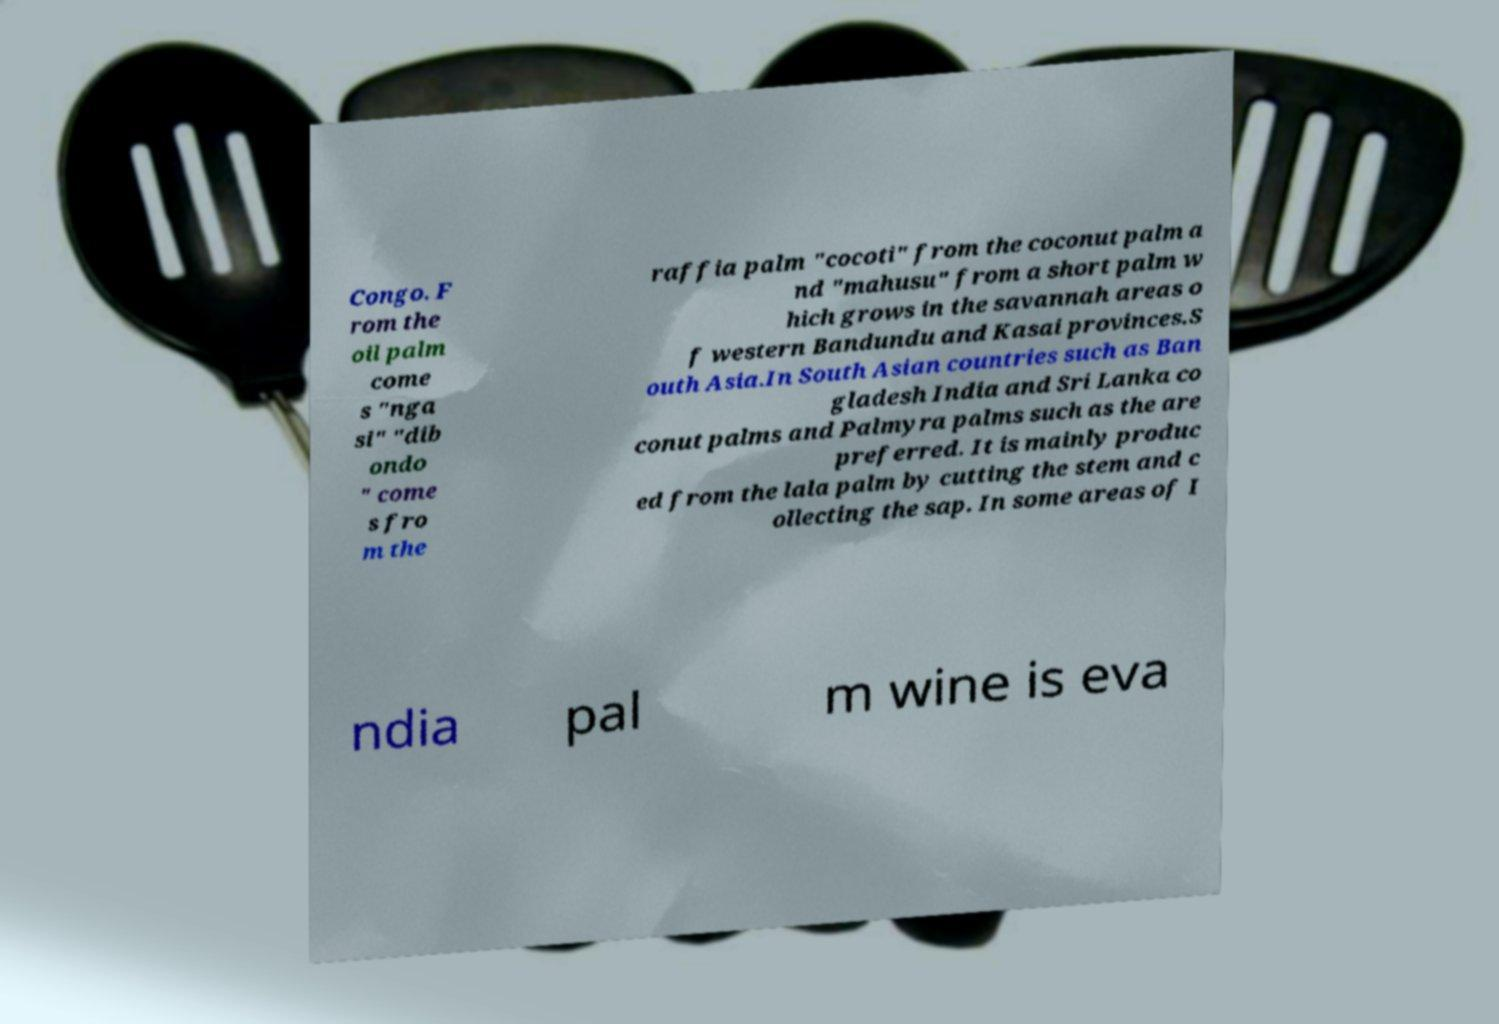Could you assist in decoding the text presented in this image and type it out clearly? Congo. F rom the oil palm come s "nga si" "dib ondo " come s fro m the raffia palm "cocoti" from the coconut palm a nd "mahusu" from a short palm w hich grows in the savannah areas o f western Bandundu and Kasai provinces.S outh Asia.In South Asian countries such as Ban gladesh India and Sri Lanka co conut palms and Palmyra palms such as the are preferred. It is mainly produc ed from the lala palm by cutting the stem and c ollecting the sap. In some areas of I ndia pal m wine is eva 